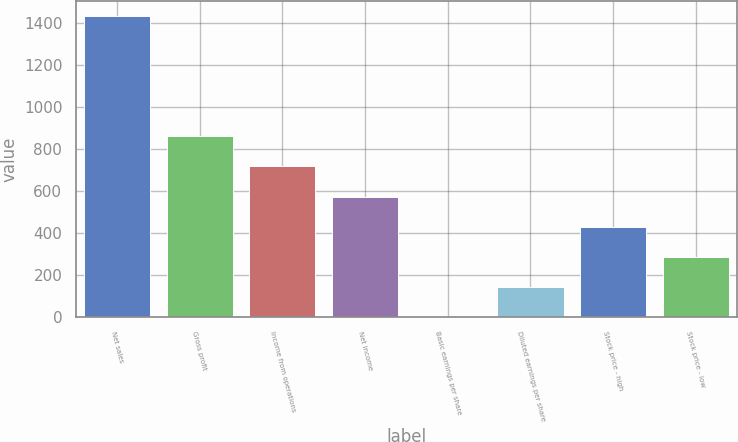Convert chart to OTSL. <chart><loc_0><loc_0><loc_500><loc_500><bar_chart><fcel>Net sales<fcel>Gross profit<fcel>Income from operations<fcel>Net income<fcel>Basic earnings per share<fcel>Diluted earnings per share<fcel>Stock price - high<fcel>Stock price - low<nl><fcel>1434<fcel>860.8<fcel>717.5<fcel>574.2<fcel>1<fcel>144.3<fcel>430.9<fcel>287.6<nl></chart> 